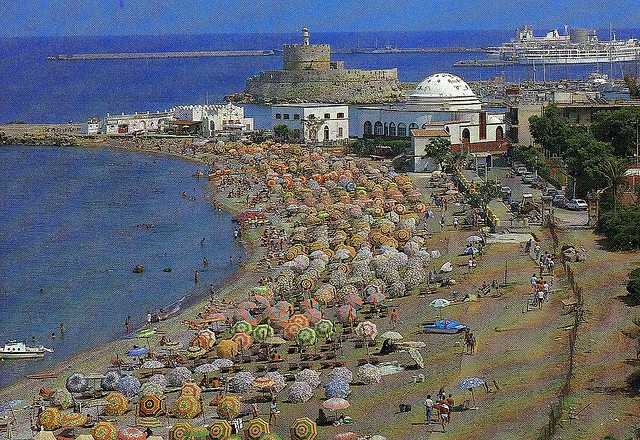Describe the objects in this image and their specific colors. I can see umbrella in blue, gray, black, darkgray, and tan tones, people in blue, gray, black, darkgray, and tan tones, boat in blue, gray, darkgray, and lightgray tones, boat in blue, white, black, gray, and darkgray tones, and umbrella in blue, black, olive, and gray tones in this image. 